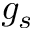<formula> <loc_0><loc_0><loc_500><loc_500>g _ { s }</formula> 